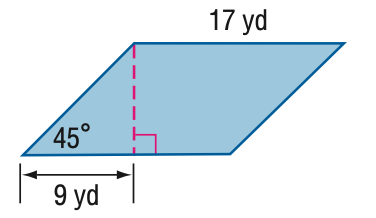Answer the mathemtical geometry problem and directly provide the correct option letter.
Question: Find the area of the parallelogram. Round to the nearest tenth if necessary.
Choices: A: 144.2 B: 153 C: 176.7 D: 288.5 B 